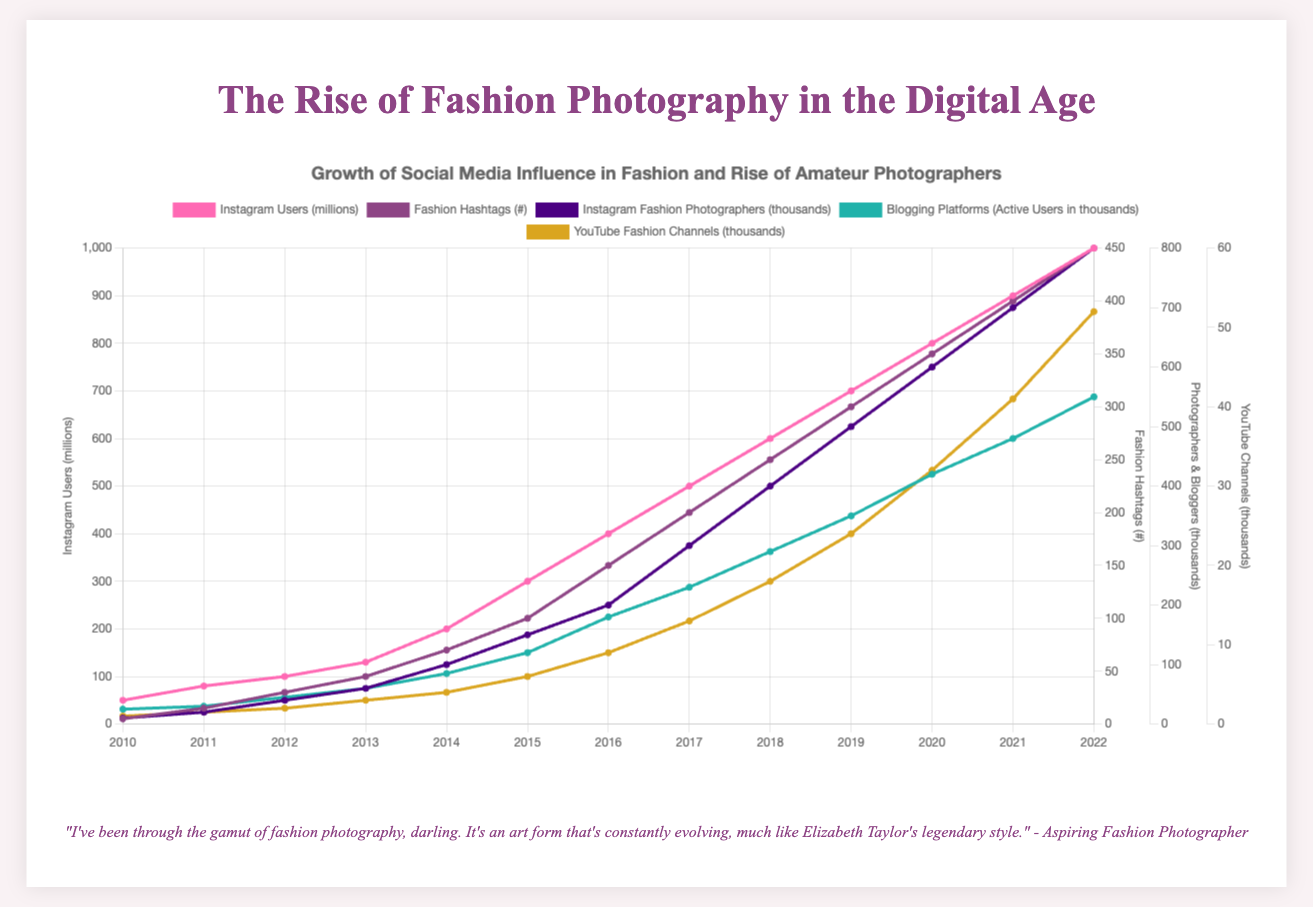What year did Instagram Users (millions) surpass 400 million? To find the year when Instagram Users surpassed 400 million, locate the data point where the value exceeds 400 million. Referring to the plot, it surpassed 400 million in 2016.
Answer: 2016 By how many thousands did Blogging Platform users increase from 2010 to 2022? Blogging Platform users were 25 thousand in 2010 and 550 thousand in 2022. To find the increase, subtract the 2010 value from the 2022 value: 550 - 25 = 525 thousand.
Answer: 525 thousand Which had a higher growth rate from 2010 to 2022: Instagram Users or YouTube Fashion Channels? To find the growth rate, calculate the difference from 2010 to 2022 for both metrics. Instagram Users grew from 50 million to 1000 million, an increase of 950 million. YouTube Channels grew from 1 thousand to 52 thousand, an increase of 51 thousand. Compare these growths relative to their initial values. The growth factor for Instagram Users is 1000/50 = 20, and for YouTube Channels, it's 52/1 = 52. Hence, YouTube Channels had a higher growth rate.
Answer: YouTube Fashion Channels In which year did Instagram Fashion Photographers (thousands) equal Blogging Platform users? Locate the year where both metrics intersect. Both are at 200 thousand in 2016.
Answer: 2016 How many more Fashion Hashtags were there in 2018 compared to 2014? Fashion Hashtags increased from 70 in 2014 to 250 in 2018. Subtract the 2014 value from the 2018 value: 250 - 70 = 180.
Answer: 180 What was the approximate ratio of Instagram Users to Fashion Hashtags in 2015? In 2015, Instagram Users were 300 million, and Fashion Hashtags were 100. The ratio is 300/100 = 3 million per hashtag.
Answer: 3 Which visual indicator grew consistently without any decline throughout all years? By visual inspection, Instagram Users (pink line) consistently increased every year.
Answer: Instagram Users Compare the changes in YouTube Fashion Channels from 2013 to 2015 and from 2018 to 2020. Which period saw a greater increase in the number of channels? The number of YouTube Fashion Channels increased from 3 thousand in 2013 to 6 thousand in 2015 (3 thousand increase), and from 18 thousand in 2018 to 32 thousand in 2020 (14 thousand increase). The second period saw a greater increase.
Answer: 2018 to 2020 